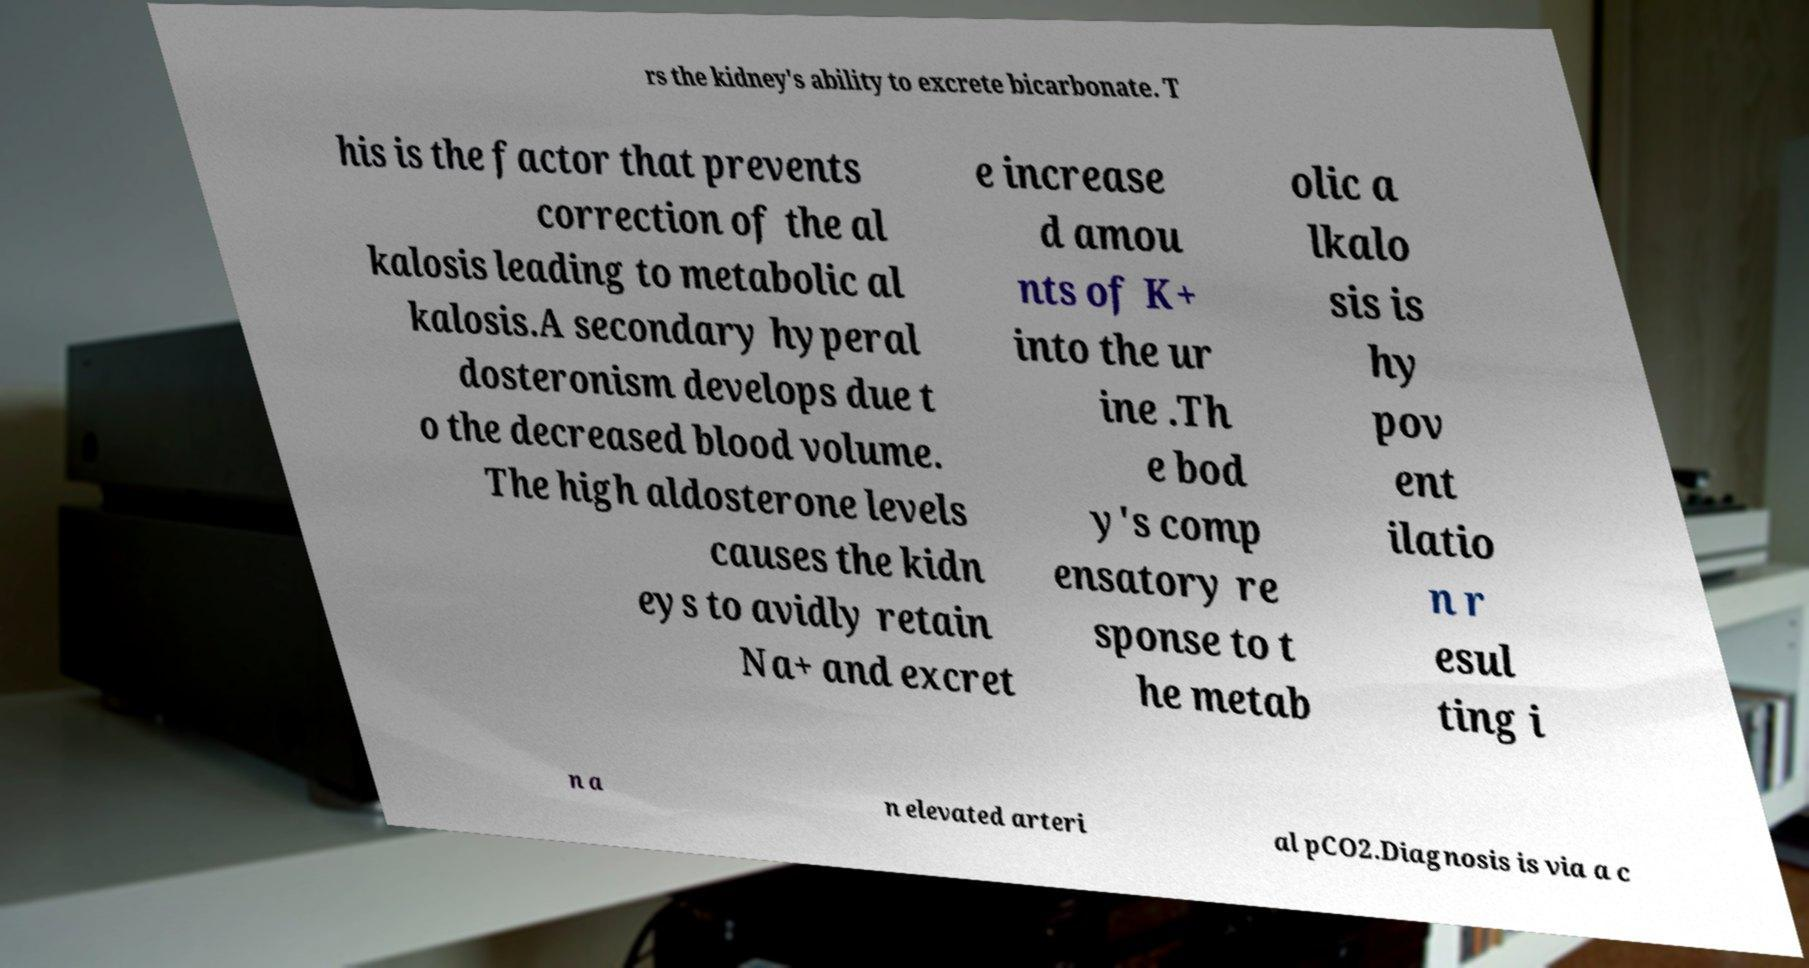I need the written content from this picture converted into text. Can you do that? rs the kidney's ability to excrete bicarbonate. T his is the factor that prevents correction of the al kalosis leading to metabolic al kalosis.A secondary hyperal dosteronism develops due t o the decreased blood volume. The high aldosterone levels causes the kidn eys to avidly retain Na+ and excret e increase d amou nts of K+ into the ur ine .Th e bod y's comp ensatory re sponse to t he metab olic a lkalo sis is hy pov ent ilatio n r esul ting i n a n elevated arteri al pCO2.Diagnosis is via a c 